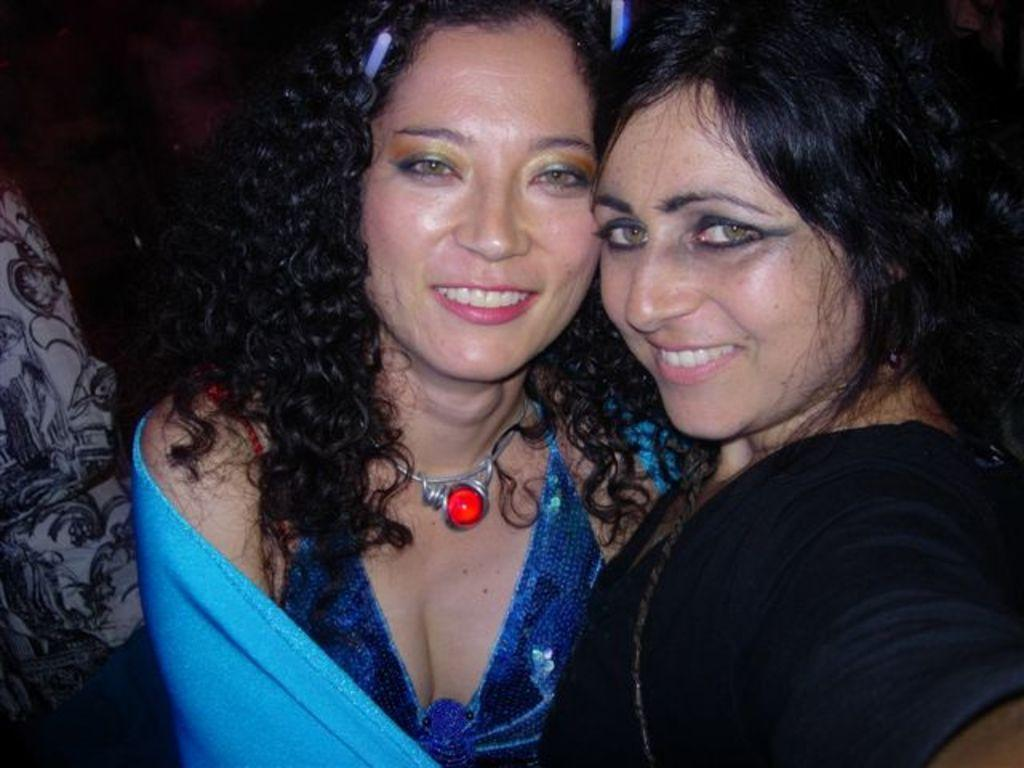How many people are in the image? There are two ladies in the image. What is the facial expression of the ladies? Both ladies are smiling. Can you describe any accessories worn by one of the ladies? One of the ladies is wearing a necklace with a red stone. What type of square substance can be seen in the image? There is no square substance present in the image. Do the ladies have fangs in the image? No, the ladies do not have fangs in the image. 